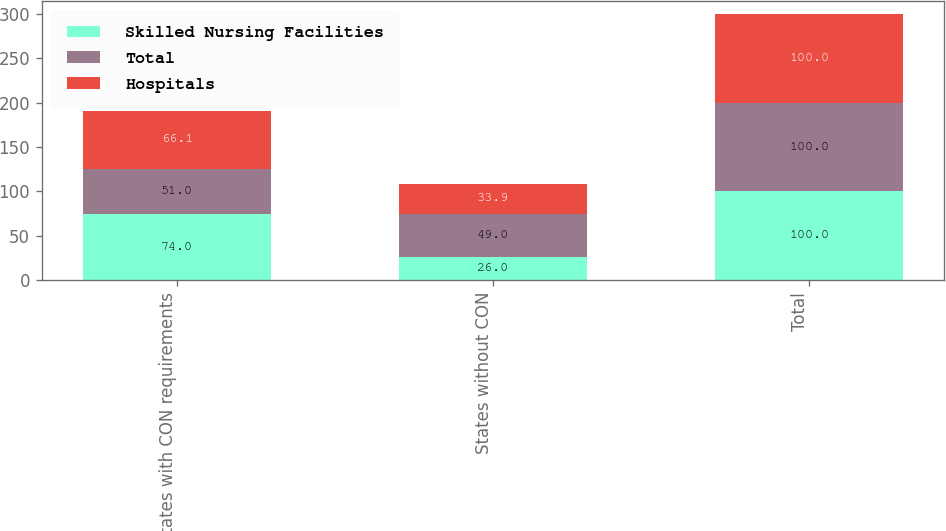Convert chart to OTSL. <chart><loc_0><loc_0><loc_500><loc_500><stacked_bar_chart><ecel><fcel>States with CON requirements<fcel>States without CON<fcel>Total<nl><fcel>Skilled Nursing Facilities<fcel>74<fcel>26<fcel>100<nl><fcel>Total<fcel>51<fcel>49<fcel>100<nl><fcel>Hospitals<fcel>66.1<fcel>33.9<fcel>100<nl></chart> 